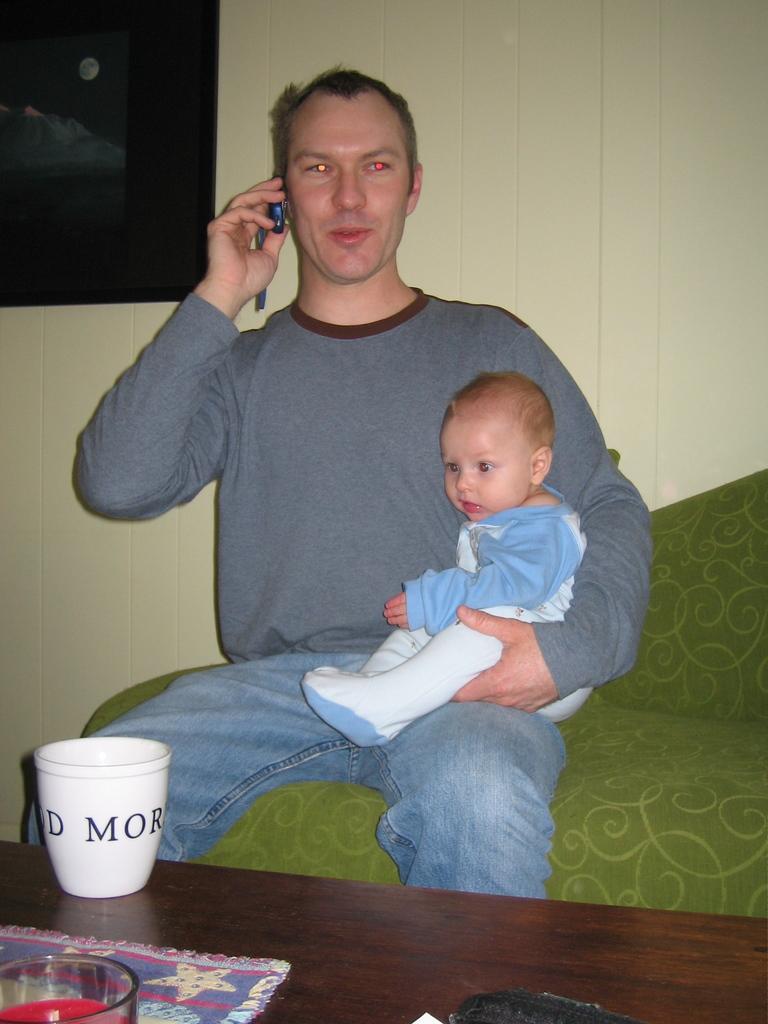How would you summarize this image in a sentence or two? Here we can see a man sitting with baby in his hand and speaking to someone in his mobile phone and in front of him we can see a table and a glass present 